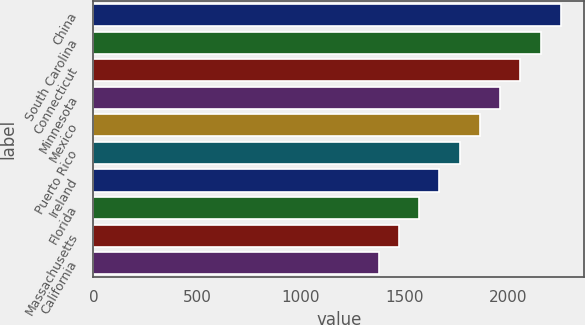Convert chart. <chart><loc_0><loc_0><loc_500><loc_500><bar_chart><fcel>China<fcel>South Carolina<fcel>Connecticut<fcel>Minnesota<fcel>Mexico<fcel>Puerto Rico<fcel>Ireland<fcel>Florida<fcel>Massachusetts<fcel>California<nl><fcel>2255.6<fcel>2158<fcel>2060.4<fcel>1962.8<fcel>1865.2<fcel>1767.6<fcel>1670<fcel>1572.4<fcel>1474.8<fcel>1377.2<nl></chart> 